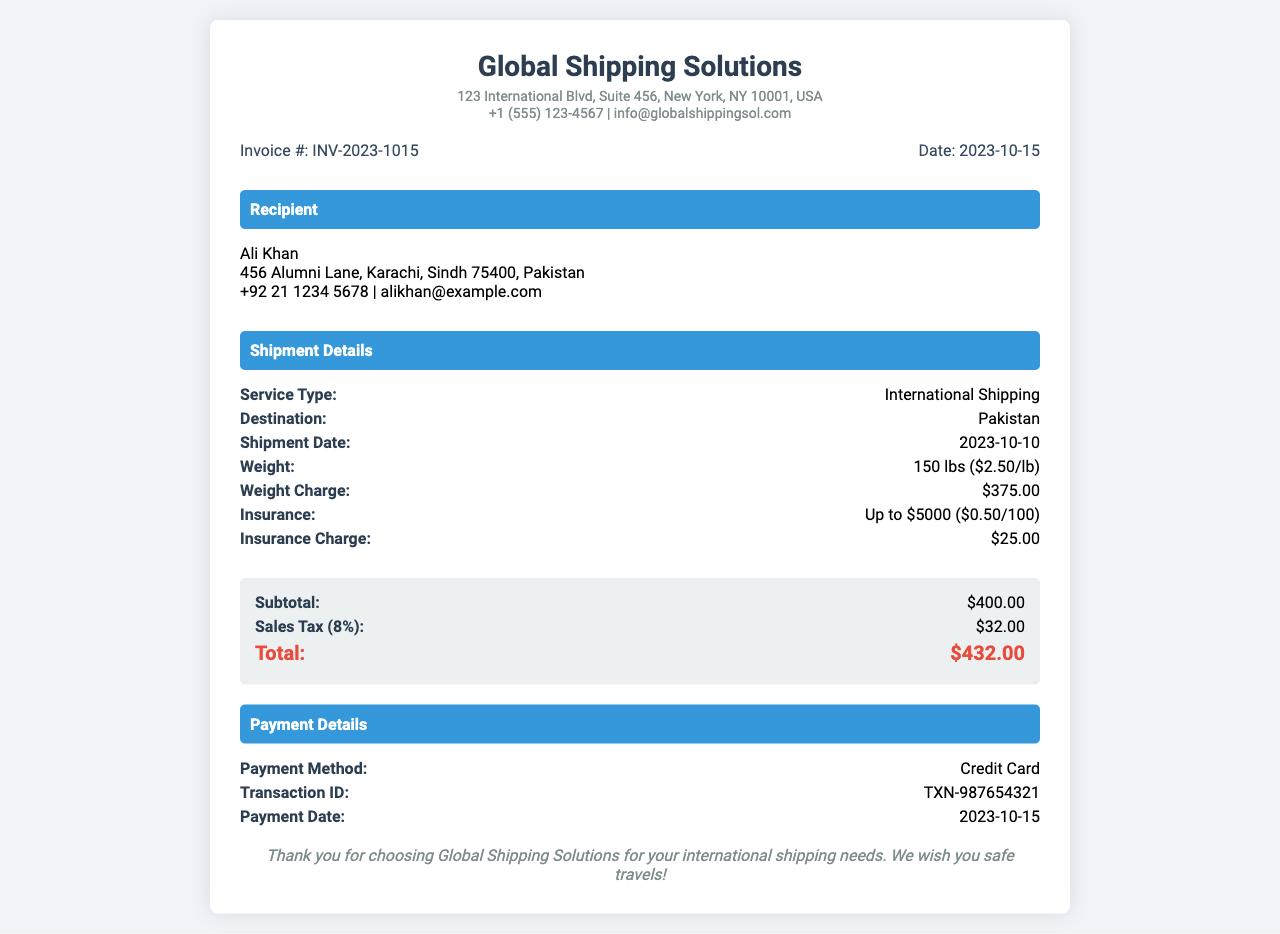what is the invoice number? The invoice number is clearly stated in the document, which is INV-2023-1015.
Answer: INV-2023-1015 who is the recipient? The recipient's name is provided in the document, which is Ali Khan.
Answer: Ali Khan what is the weight of the shipment? The weight of the shipment, mentioned in the document, is 150 lbs.
Answer: 150 lbs what is the total amount charged? The total amount charged is summed up in the charges section as $432.00.
Answer: $432.00 what date was the shipment made? The shipment date is noted in the shipment details, which is 2023-10-10.
Answer: 2023-10-10 how much is the insurance charge? The document specifies the insurance charge as $25.00.
Answer: $25.00 what service type is listed? The service type for the shipment is mentioned as International Shipping.
Answer: International Shipping what payment method was used? The method of payment used, as listed in the payment details, is Credit Card.
Answer: Credit Card what is the subtotal before tax? The subtotal before tax is explicitly stated in the document as $400.00.
Answer: $400.00 